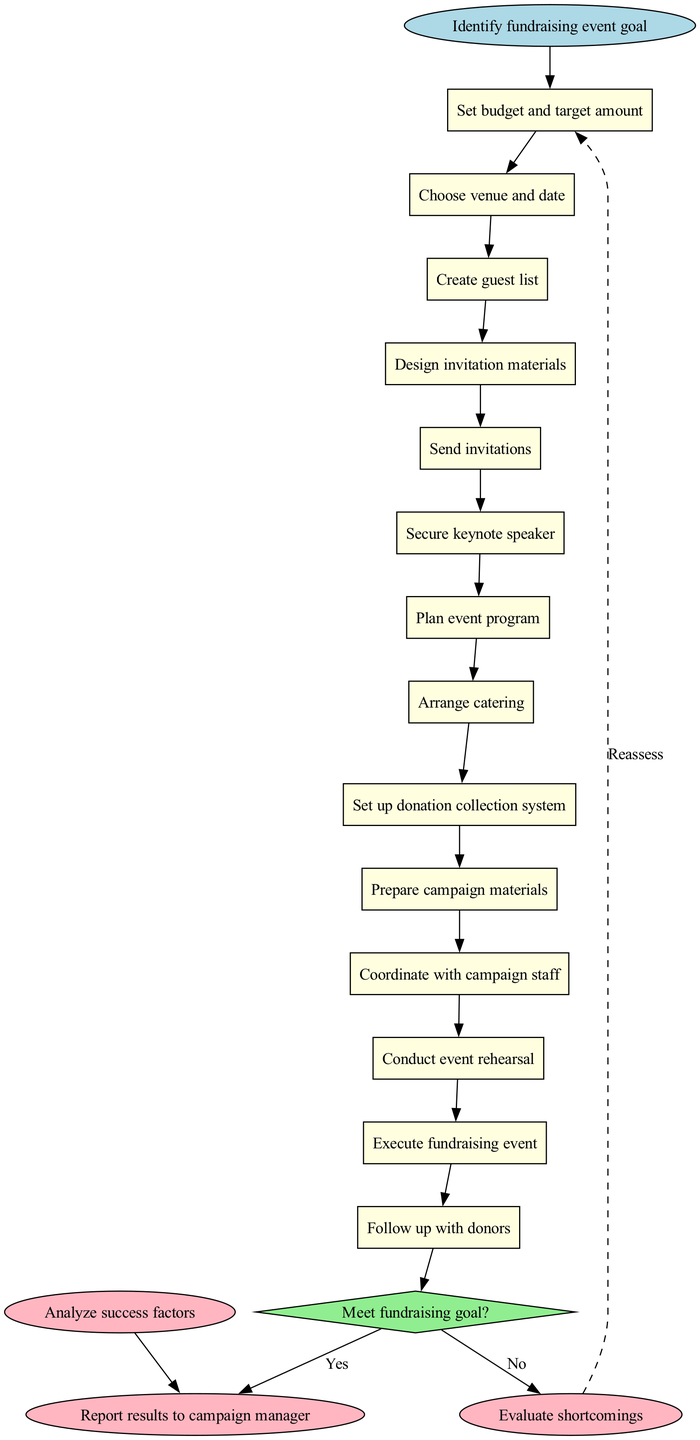What is the first activity in the diagram? The first activity is indicated directly after the start node, which is "Set budget and target amount."
Answer: Set budget and target amount How many activities are in total? The diagram lists 12 activities in total. Each activity is represented as a rectangle, and by counting them, we confirm there are indeed 12.
Answer: 12 What is the decision point labeled as? The decision point is labeled "Meet fundraising goal?" and is represented as a diamond shape in the diagram.
Answer: Meet fundraising goal? What happens if the fundraising goal is met? If the fundraising goal is met, the diagram indicates that the process will flow to "Analyze success factors," which is the next step.
Answer: Analyze success factors What does the dashed edge indicate in the diagram? The dashed edge from "Evaluate shortcomings" back to "Set budget and target amount" signifies a reassessment or return to an earlier activity if the goal is not met.
Answer: Reassess How many decision outcomes are represented? There are two outcomes represented for the decision point: "Yes" and "No," leading to different next steps based on whether the fundraising goal was met.
Answer: 2 What activity follows the "Send invitations"? The activity that follows "Send invitations" is "Secure keynote speaker," indicating the sequential flow from one task to another.
Answer: Secure keynote speaker How does the diagram end? The diagram concludes with the node labeled "Report results to campaign manager," which is the final step of the flow.
Answer: Report results to campaign manager What activity is performed after "Conduct event rehearsal"? After conducting the event rehearsal, the next activity is "Execute fundraising event," signifying that the actual event takes place following the rehearsal.
Answer: Execute fundraising event 